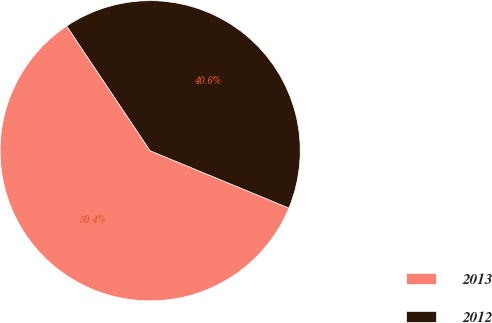<chart> <loc_0><loc_0><loc_500><loc_500><pie_chart><fcel>2013<fcel>2012<nl><fcel>59.38%<fcel>40.62%<nl></chart> 